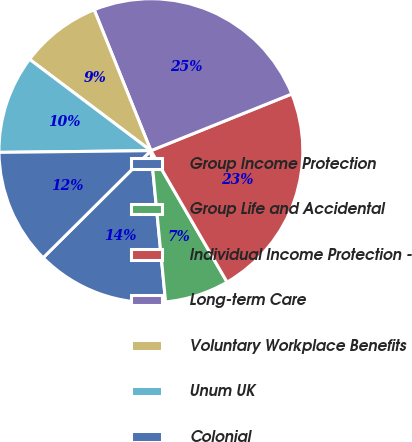Convert chart. <chart><loc_0><loc_0><loc_500><loc_500><pie_chart><fcel>Group Income Protection<fcel>Group Life and Accidental<fcel>Individual Income Protection -<fcel>Long-term Care<fcel>Voluntary Workplace Benefits<fcel>Unum UK<fcel>Colonial<nl><fcel>14.09%<fcel>6.82%<fcel>22.73%<fcel>25.0%<fcel>8.64%<fcel>10.45%<fcel>12.27%<nl></chart> 